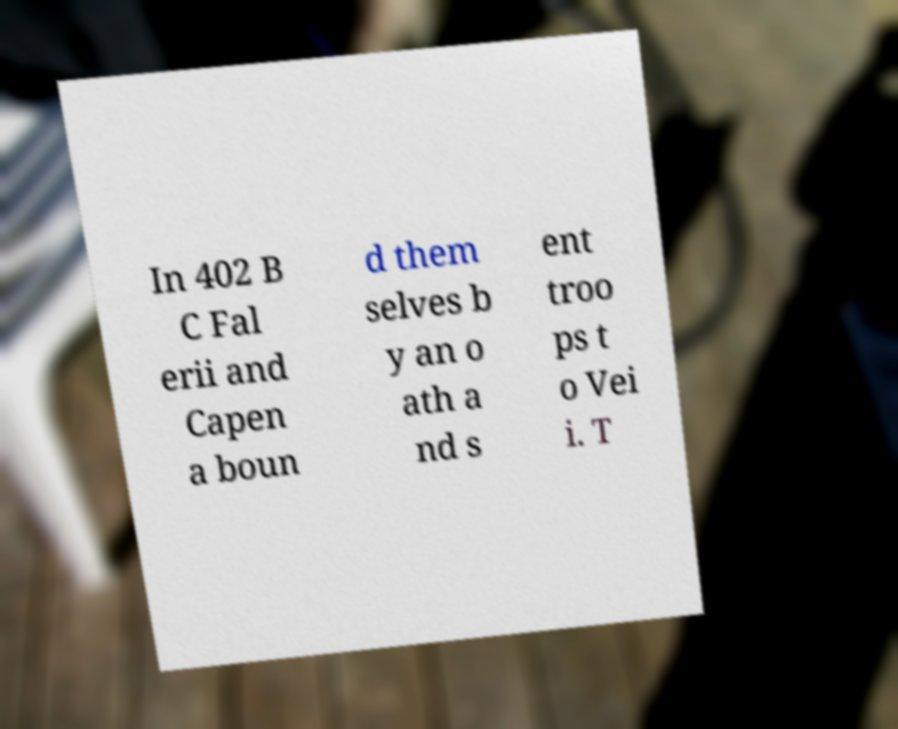Could you extract and type out the text from this image? In 402 B C Fal erii and Capen a boun d them selves b y an o ath a nd s ent troo ps t o Vei i. T 